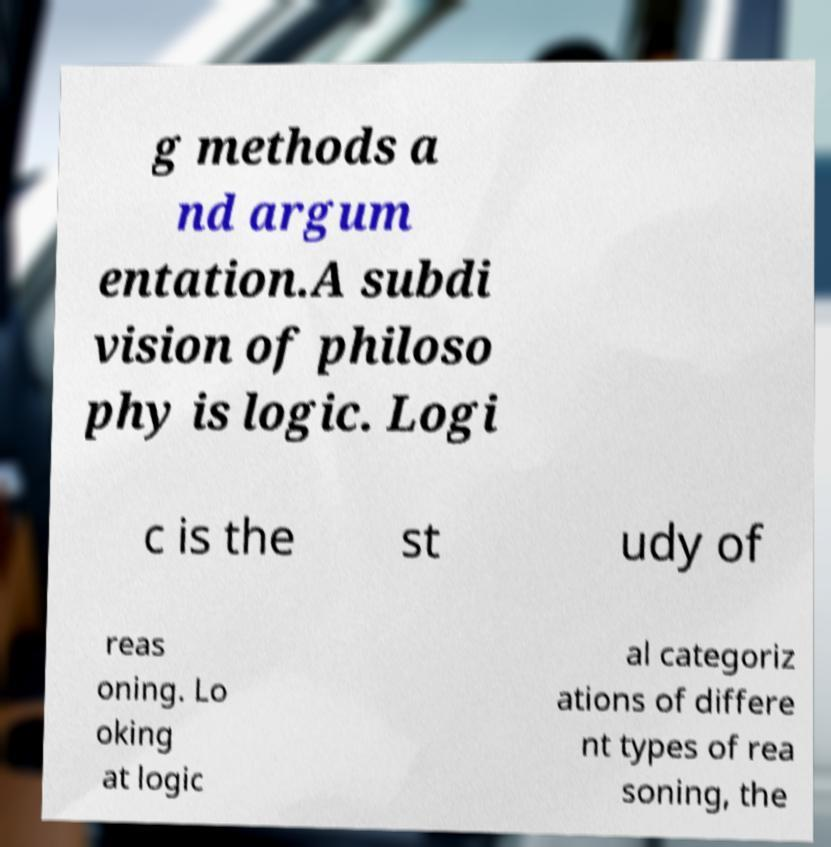Can you read and provide the text displayed in the image?This photo seems to have some interesting text. Can you extract and type it out for me? g methods a nd argum entation.A subdi vision of philoso phy is logic. Logi c is the st udy of reas oning. Lo oking at logic al categoriz ations of differe nt types of rea soning, the 